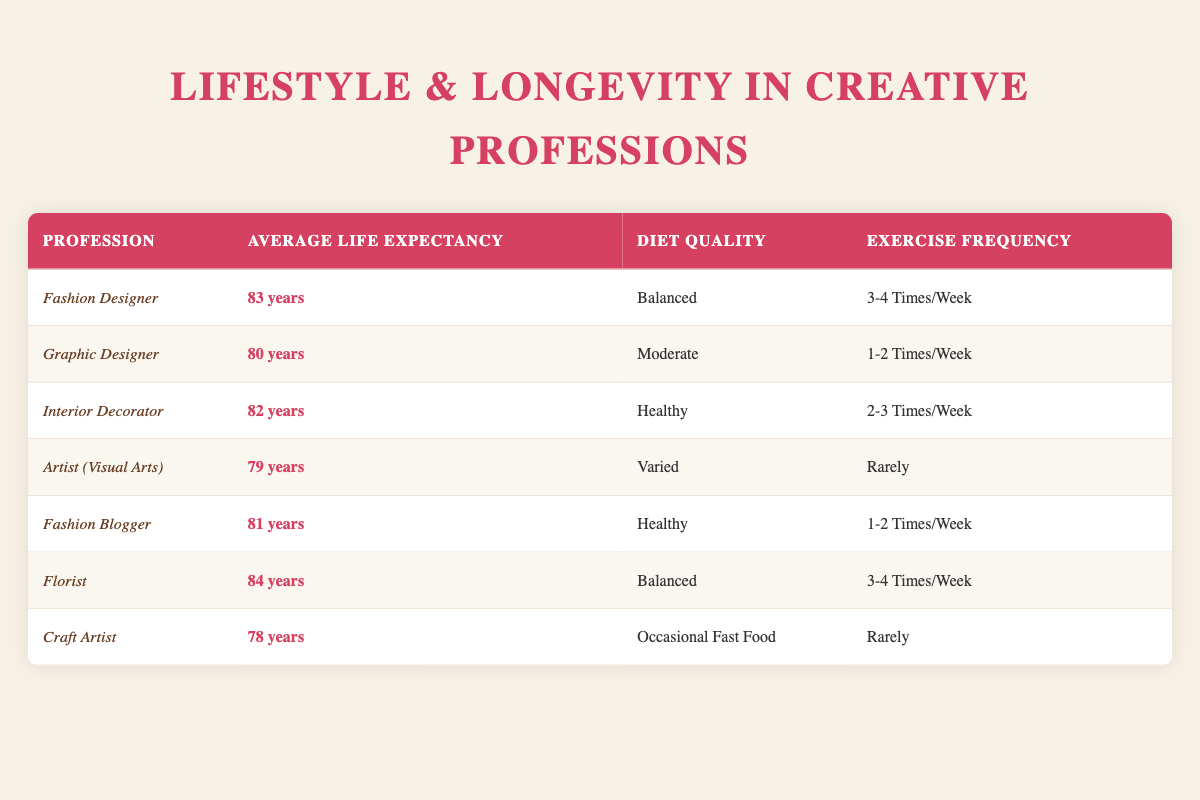What is the average life expectancy of a fashion designer? The table indicates that the average life expectancy of a fashion designer is listed under the "Average Life Expectancy" column for that profession. Referring to the table, it shows that the life expectancy is 83 years.
Answer: 83 years Which profession has the highest average life expectancy? By examining the "Average Life Expectancy" column, we see that the Florist has the highest average life expectancy at 84 years, higher than all other professions listed.
Answer: Florist What is the diet quality of a graphic designer? Looking at the "Diet Quality" column corresponding to the Graphic Designer in the table, it states that the diet quality for this profession is "Moderate."
Answer: Moderate Are the exercise frequencies of artists generally lower than those of fashion designers? The exercise frequency for the Artist (Visual Arts) is "Rarely," while for the Fashion Designer, it is "3-4 times/week." Comparatively, "Rarely" is lower than "3-4 times/week," confirming that artists have lower exercise frequencies.
Answer: Yes Which profession has the same diet quality as the interior decorator? The diet quality of the Interior Decorator is "Healthy." Scanning through the table, we see that the Fashion Blogger also has a "Healthy" diet quality. Thus, both share the same diet quality.
Answer: Fashion Blogger Calculate the average life expectancy of professions with balanced diet quality. The professions with a balanced diet quality are the Fashion Designer and Florist, with life expectancies of 83 and 84 years, respectively. To find the average: (83 + 84) / 2 = 83.5 years.
Answer: 83.5 years Does the Craft Artist have a higher average life expectancy than the Graphic Designer? The Craft Artist’s average life expectancy is 78 years, while the Graphic Designer's is 80 years. Comparing these values, 78 is not greater than 80, indicating that the Craft Artist does not have a higher average life expectancy.
Answer: No What is the difference in average life expectancy between the Florist and the Artist (Visual Arts)? The average life expectancy of the Florist is 84 years and that of the Artist (Visual Arts) is 79 years. The difference is calculated as 84 - 79 = 5 years.
Answer: 5 years Which profession exercises more frequently, the Graphic Designer or the Interior Decorator? Reviewing the exercise frequency, the Graphic Designer exercises "1-2 times/week," while the Interior Decorator exercises "2-3 times/week." Since "2-3 times/week" is more frequent than "1-2 times/week," the Interior Decorator exercises more.
Answer: Interior Decorator 